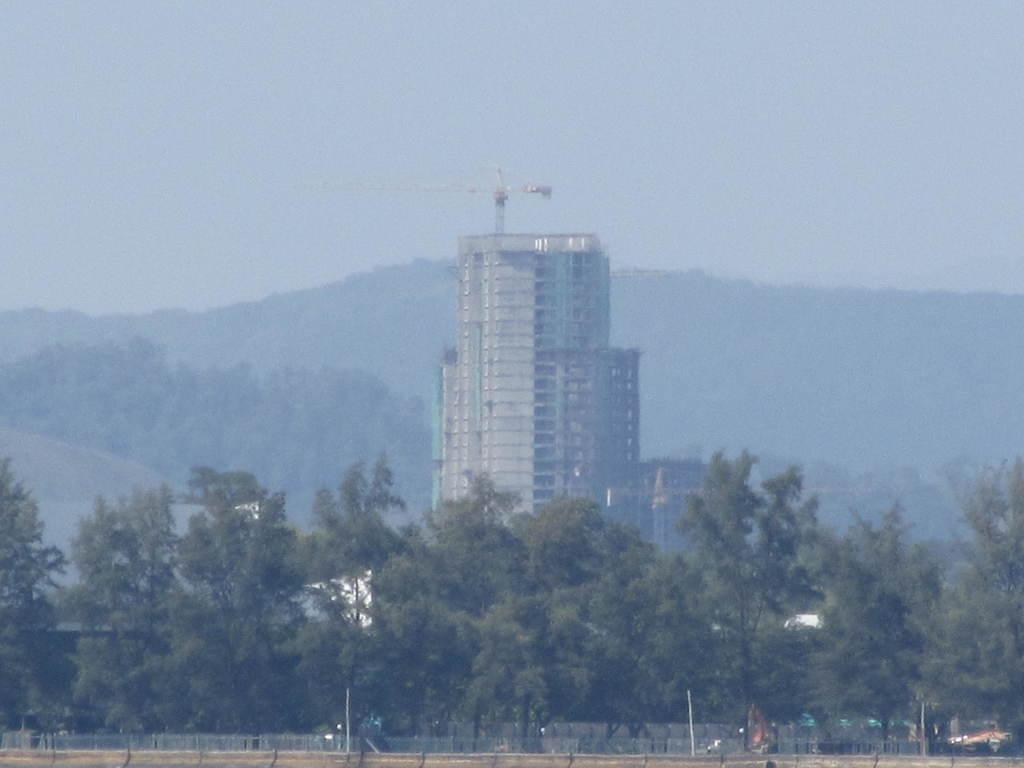What can be seen in the foreground of the image? There are trees and fencing in the foreground of the image. What is located in the background of the image? There is a building and a mountain in the background of the image. What part of the natural environment is visible in the image? The sky is visible in the background of the image. Can you tell me how many nails are used to hold the fence together in the image? There is no information about nails or the fence's construction in the image, so it is not possible to determine the number of nails used. What type of animal can be seen grazing on the grass near the trees in the image? There is no animal present in the image; it only features trees, fencing, a building, a mountain, and the sky. 